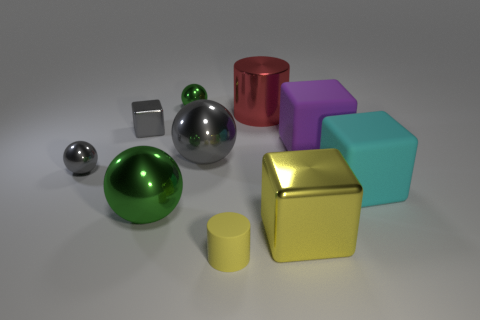Subtract 1 blocks. How many blocks are left? 3 Subtract all cylinders. How many objects are left? 8 Add 8 small gray blocks. How many small gray blocks are left? 9 Add 7 yellow metal things. How many yellow metal things exist? 8 Subtract 0 brown cylinders. How many objects are left? 10 Subtract all large yellow metal objects. Subtract all green matte spheres. How many objects are left? 9 